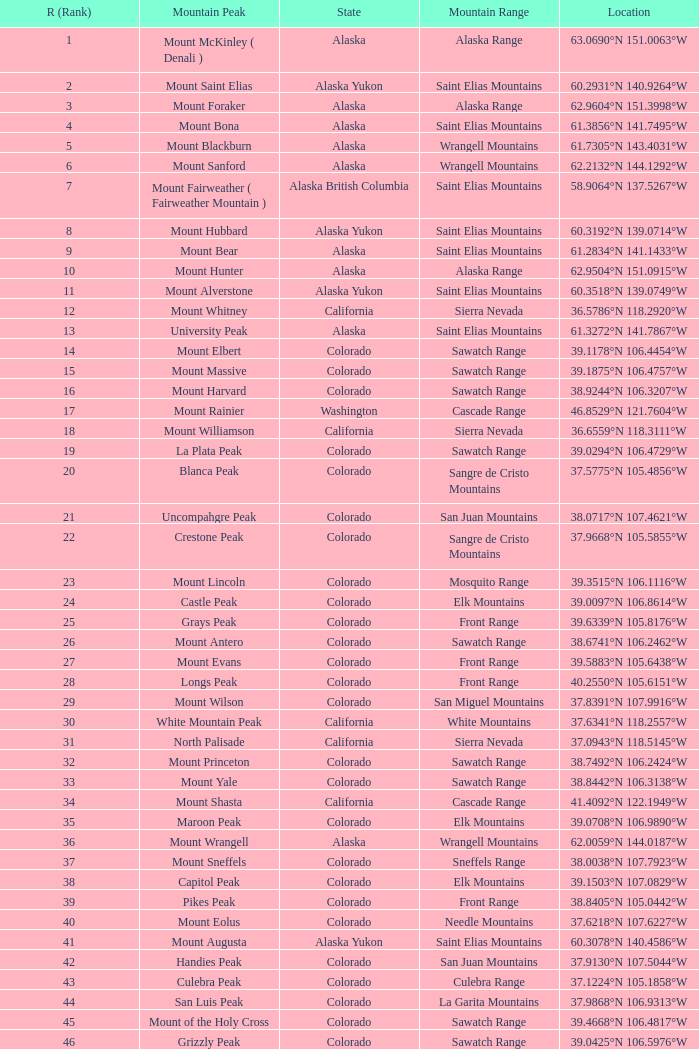What is the mountain range when the mountain peak is mauna kea? Island of Hawai ʻ i. 